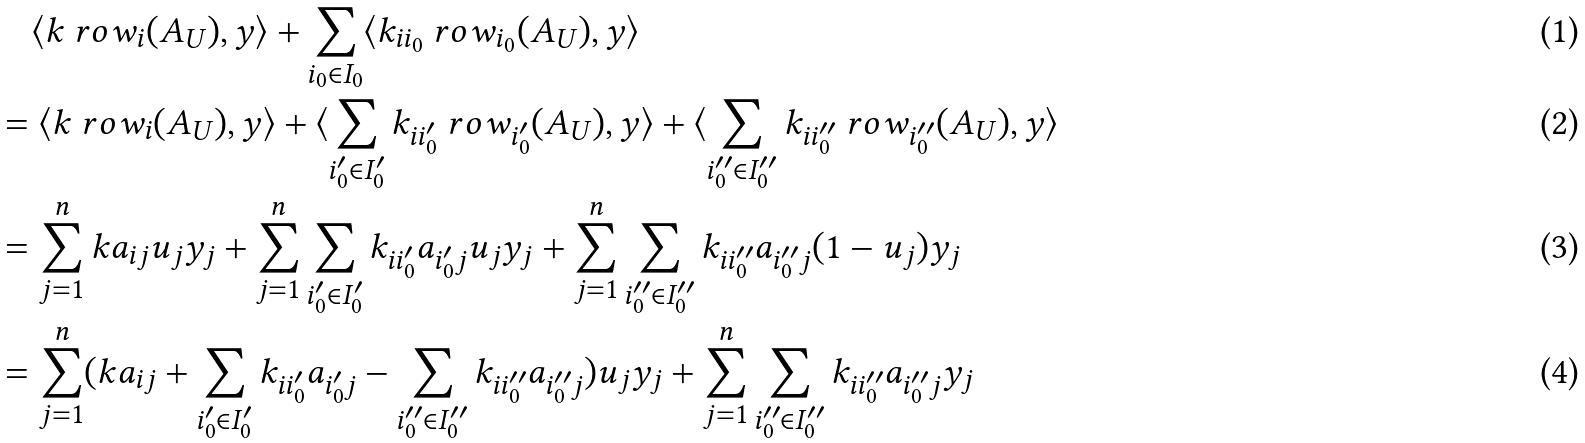<formula> <loc_0><loc_0><loc_500><loc_500>& \quad \langle k \ r o w _ { i } ( A _ { U } ) , y \rangle + \sum _ { i _ { 0 } \in I _ { 0 } } \langle k _ { i i _ { 0 } } \ r o w _ { i _ { 0 } } ( A _ { U } ) , y \rangle \\ & = \langle k \ r o w _ { i } ( A _ { U } ) , y \rangle + \langle \sum _ { i _ { 0 } ^ { \prime } \in I _ { 0 } ^ { \prime } } k _ { i i _ { 0 } ^ { \prime } } \ r o w _ { i _ { 0 } ^ { \prime } } ( A _ { U } ) , y \rangle + \langle \sum _ { i _ { 0 } ^ { \prime \prime } \in I _ { 0 } ^ { \prime \prime } } k _ { i i _ { 0 } ^ { \prime \prime } } \ r o w _ { i _ { 0 } ^ { \prime \prime } } ( A _ { U } ) , y \rangle \\ & = \sum _ { j = 1 } ^ { n } k a _ { i j } u _ { j } y _ { j } + \sum _ { j = 1 } ^ { n } \sum _ { i _ { 0 } ^ { \prime } \in I _ { 0 } ^ { \prime } } k _ { i i _ { 0 } ^ { \prime } } a _ { i _ { 0 } ^ { \prime } j } u _ { j } y _ { j } + \sum _ { j = 1 } ^ { n } \sum _ { i _ { 0 } ^ { \prime \prime } \in I _ { 0 } ^ { \prime \prime } } k _ { i i _ { 0 } ^ { \prime \prime } } a _ { i _ { 0 } ^ { \prime \prime } j } ( 1 - u _ { j } ) y _ { j } \\ & = \sum _ { j = 1 } ^ { n } ( k a _ { i j } + \sum _ { i _ { 0 } ^ { \prime } \in I _ { 0 } ^ { \prime } } k _ { i i _ { 0 } ^ { \prime } } a _ { i _ { 0 } ^ { \prime } j } - \sum _ { i _ { 0 } ^ { \prime \prime } \in I _ { 0 } ^ { \prime \prime } } k _ { i i _ { 0 } ^ { \prime \prime } } a _ { i _ { 0 } ^ { \prime \prime } j } ) u _ { j } y _ { j } + \sum _ { j = 1 } ^ { n } \sum _ { i _ { 0 } ^ { \prime \prime } \in I _ { 0 } ^ { \prime \prime } } k _ { i i _ { 0 } ^ { \prime \prime } } a _ { i _ { 0 } ^ { \prime \prime } j } y _ { j }</formula> 